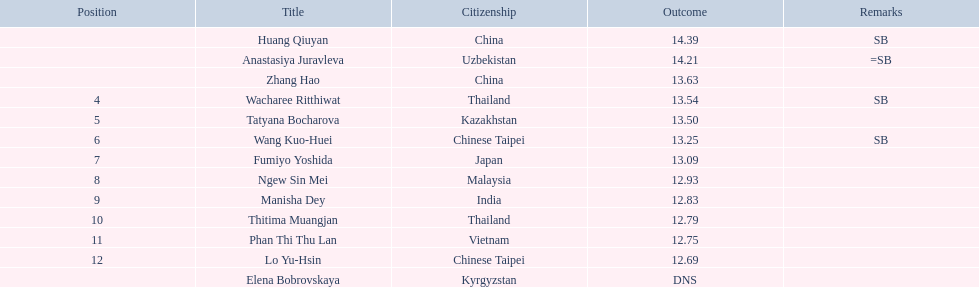What was the median performance of the top three jumpers? 14.08. 